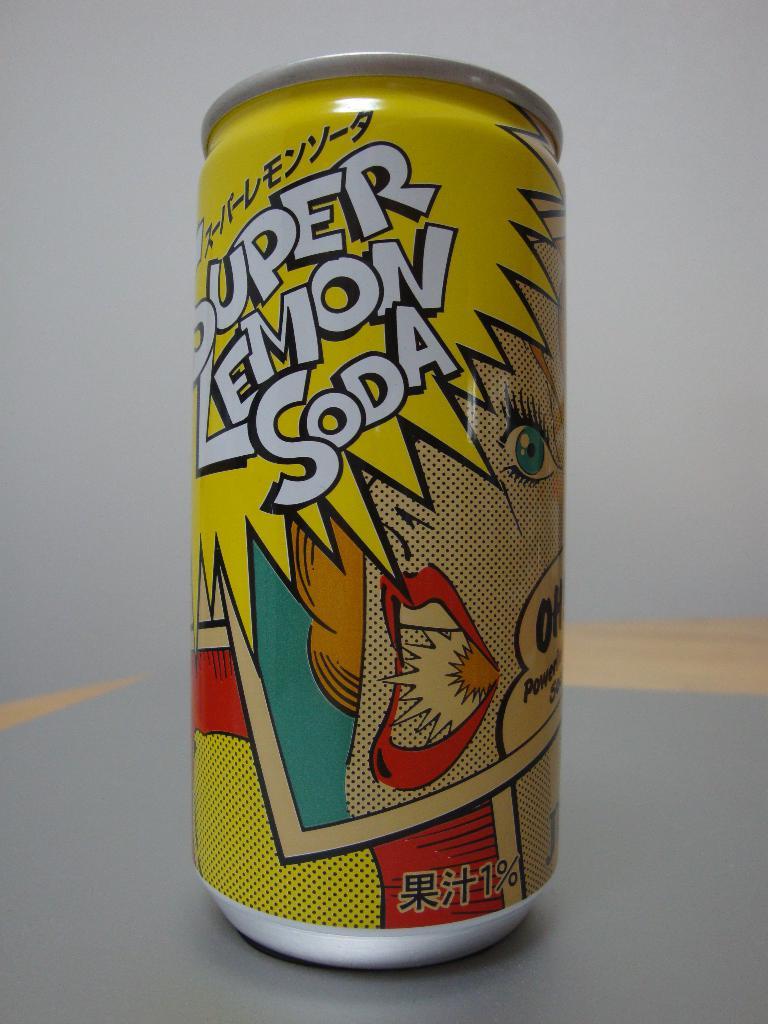What flavour is this soda?
Your answer should be very brief. Lemon. Is the lemon soda regular or super?
Make the answer very short. Super. 